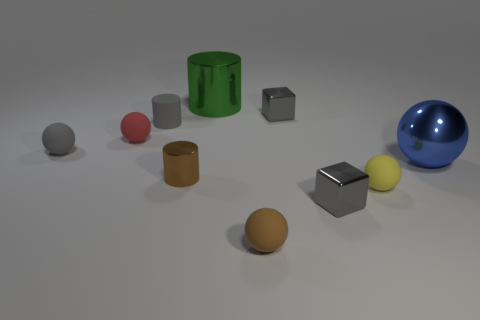There is a tiny thing that is both behind the large blue thing and to the right of the brown sphere; what is its color?
Ensure brevity in your answer.  Gray. There is a tiny gray cube in front of the tiny red object; what is its material?
Offer a very short reply. Metal. Is there a gray matte thing that has the same shape as the tiny brown shiny object?
Offer a very short reply. Yes. How many other objects are there of the same shape as the large green shiny thing?
Provide a short and direct response. 2. There is a yellow rubber object; is its shape the same as the big thing behind the small gray rubber ball?
Provide a succinct answer. No. Are there any other things that have the same material as the big blue ball?
Provide a succinct answer. Yes. What is the material of the yellow object that is the same shape as the red rubber thing?
Your answer should be compact. Rubber. What number of big things are gray shiny blocks or metal things?
Give a very brief answer. 2. Is the number of tiny cylinders on the right side of the brown cylinder less than the number of matte spheres that are right of the blue metallic object?
Your answer should be compact. No. How many things are green metallic cylinders or big metallic spheres?
Provide a succinct answer. 2. 